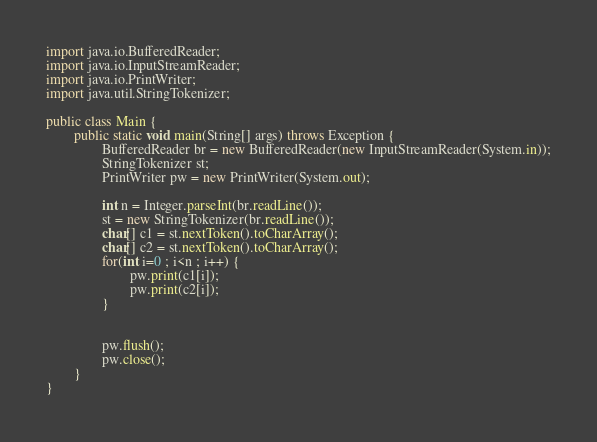<code> <loc_0><loc_0><loc_500><loc_500><_Java_>import java.io.BufferedReader;
import java.io.InputStreamReader;
import java.io.PrintWriter;
import java.util.StringTokenizer;

public class Main {
        public static void main(String[] args) throws Exception {
                BufferedReader br = new BufferedReader(new InputStreamReader(System.in));
                StringTokenizer st;
                PrintWriter pw = new PrintWriter(System.out);

                int n = Integer.parseInt(br.readLine());
                st = new StringTokenizer(br.readLine());
                char[] c1 = st.nextToken().toCharArray();
                char[] c2 = st.nextToken().toCharArray();
                for(int i=0 ; i<n ; i++) {
                        pw.print(c1[i]);
                        pw.print(c2[i]);
                }


                pw.flush();
                pw.close();
        }
}
</code> 